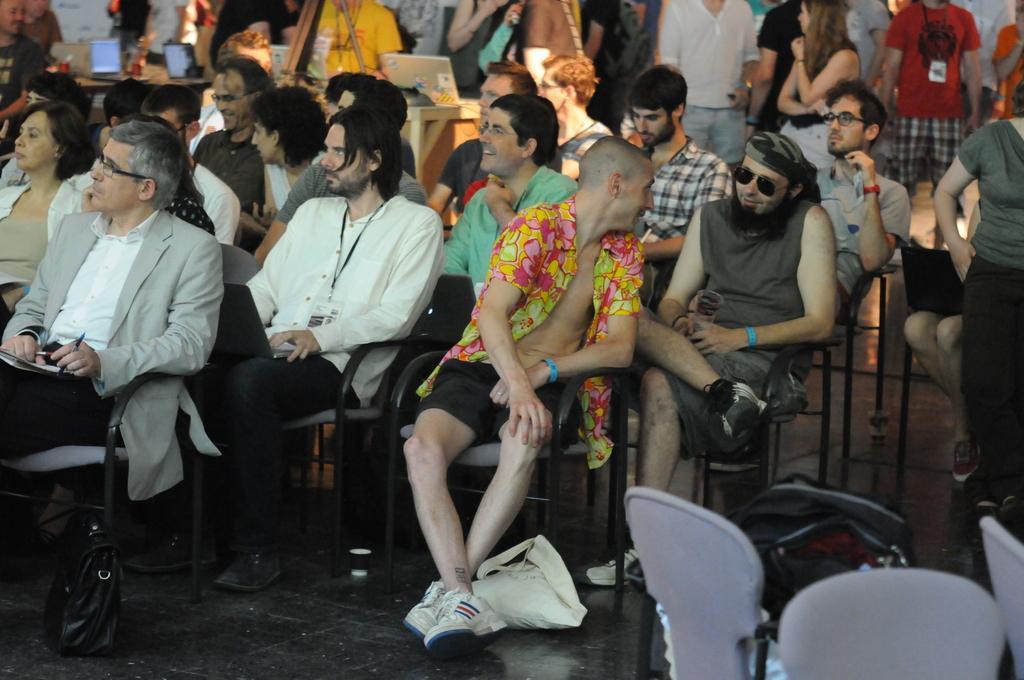How would you summarize this image in a sentence or two? In this image we can see some group of persons sitting on chairs and some are standing and we can see some bags, laptops and some other items in the image. 